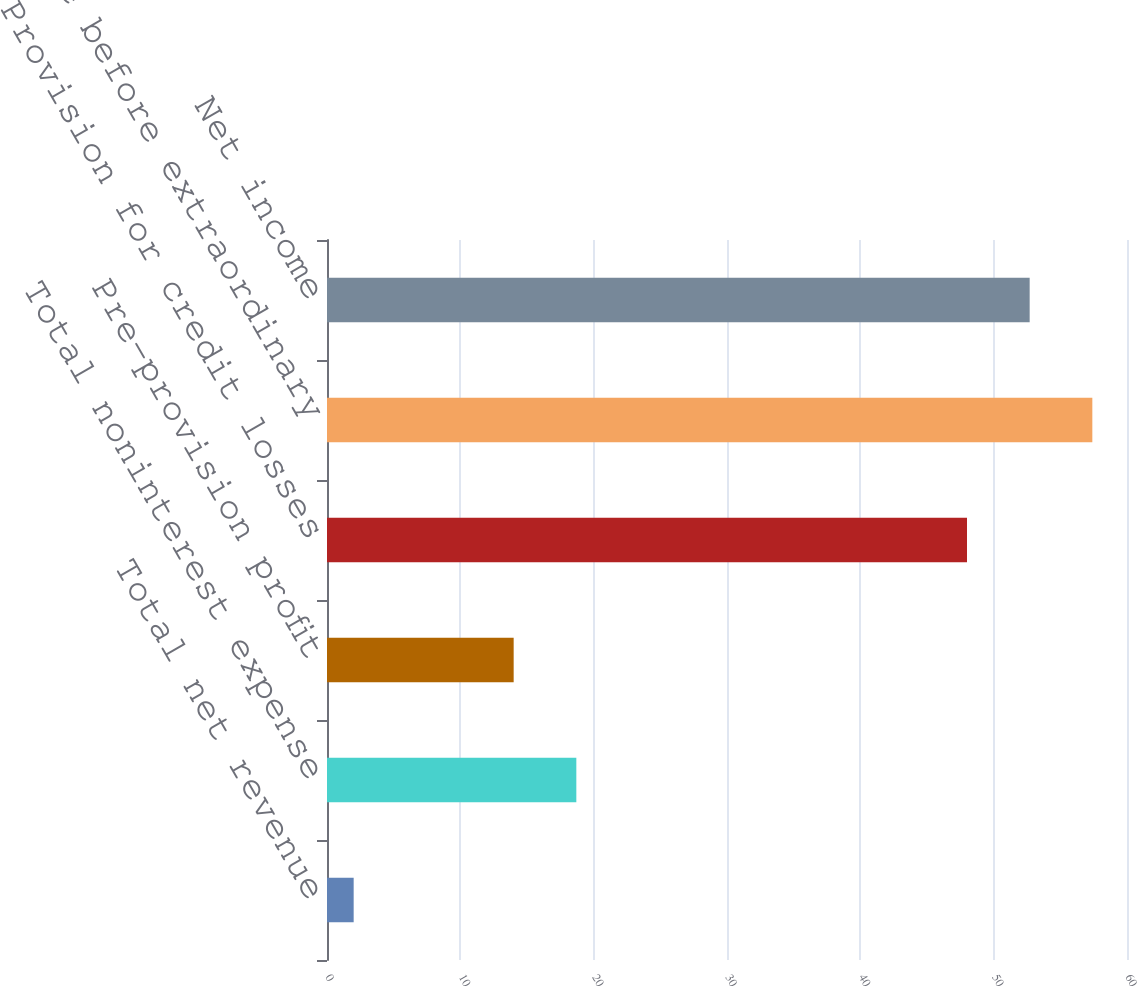Convert chart. <chart><loc_0><loc_0><loc_500><loc_500><bar_chart><fcel>Total net revenue<fcel>Total noninterest expense<fcel>Pre-provision profit<fcel>Provision for credit losses<fcel>Income before extraordinary<fcel>Net income<nl><fcel>2<fcel>18.7<fcel>14<fcel>48<fcel>57.4<fcel>52.7<nl></chart> 